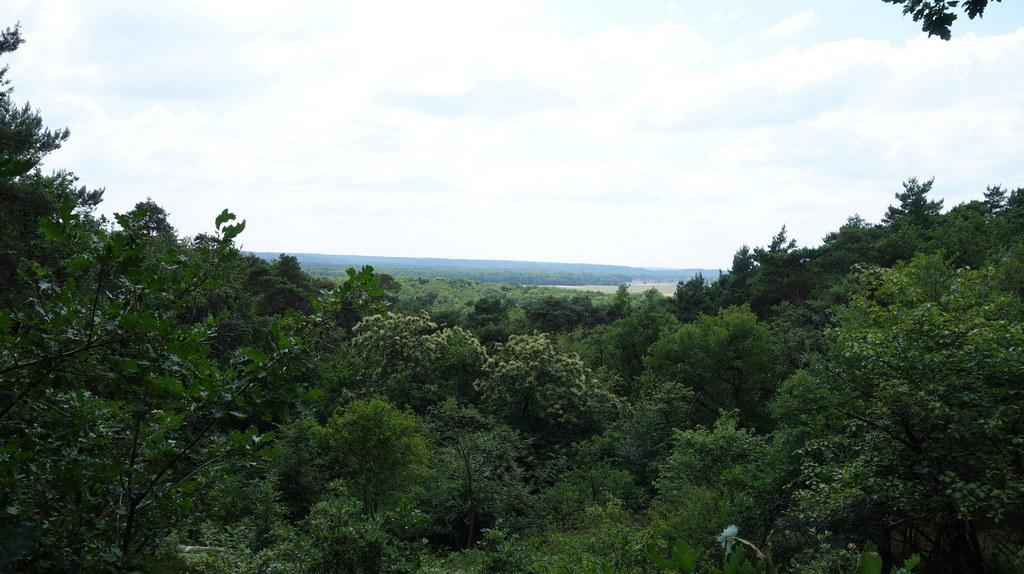What type of vegetation can be seen in the image? There are trees in the image. What part of the natural environment is visible in the image? The sky is visible in the background of the image. What type of vegetable is growing on the trees in the image? There are no vegetables growing on the trees in the image; the trees are not depicted as having any fruit or vegetable. 